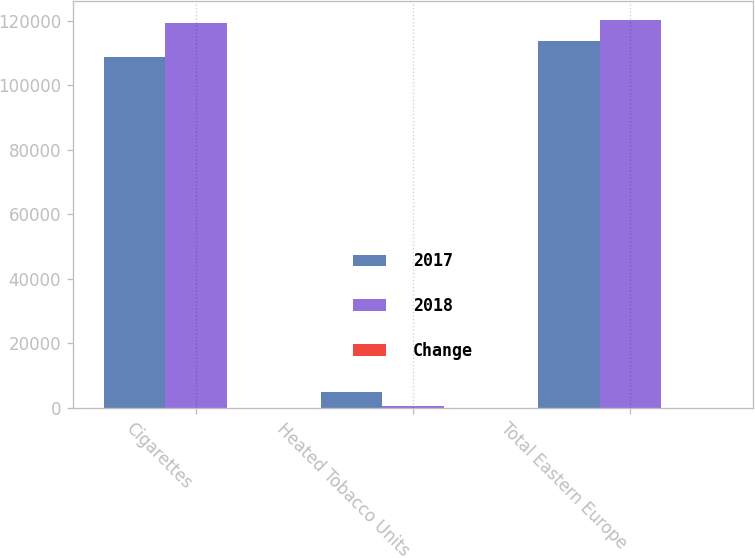Convert chart to OTSL. <chart><loc_0><loc_0><loc_500><loc_500><stacked_bar_chart><ecel><fcel>Cigarettes<fcel>Heated Tobacco Units<fcel>Total Eastern Europe<nl><fcel>2017<fcel>108718<fcel>4979<fcel>113697<nl><fcel>2018<fcel>119398<fcel>674<fcel>120072<nl><fcel>Change<fcel>8.9<fcel>100<fcel>5.3<nl></chart> 